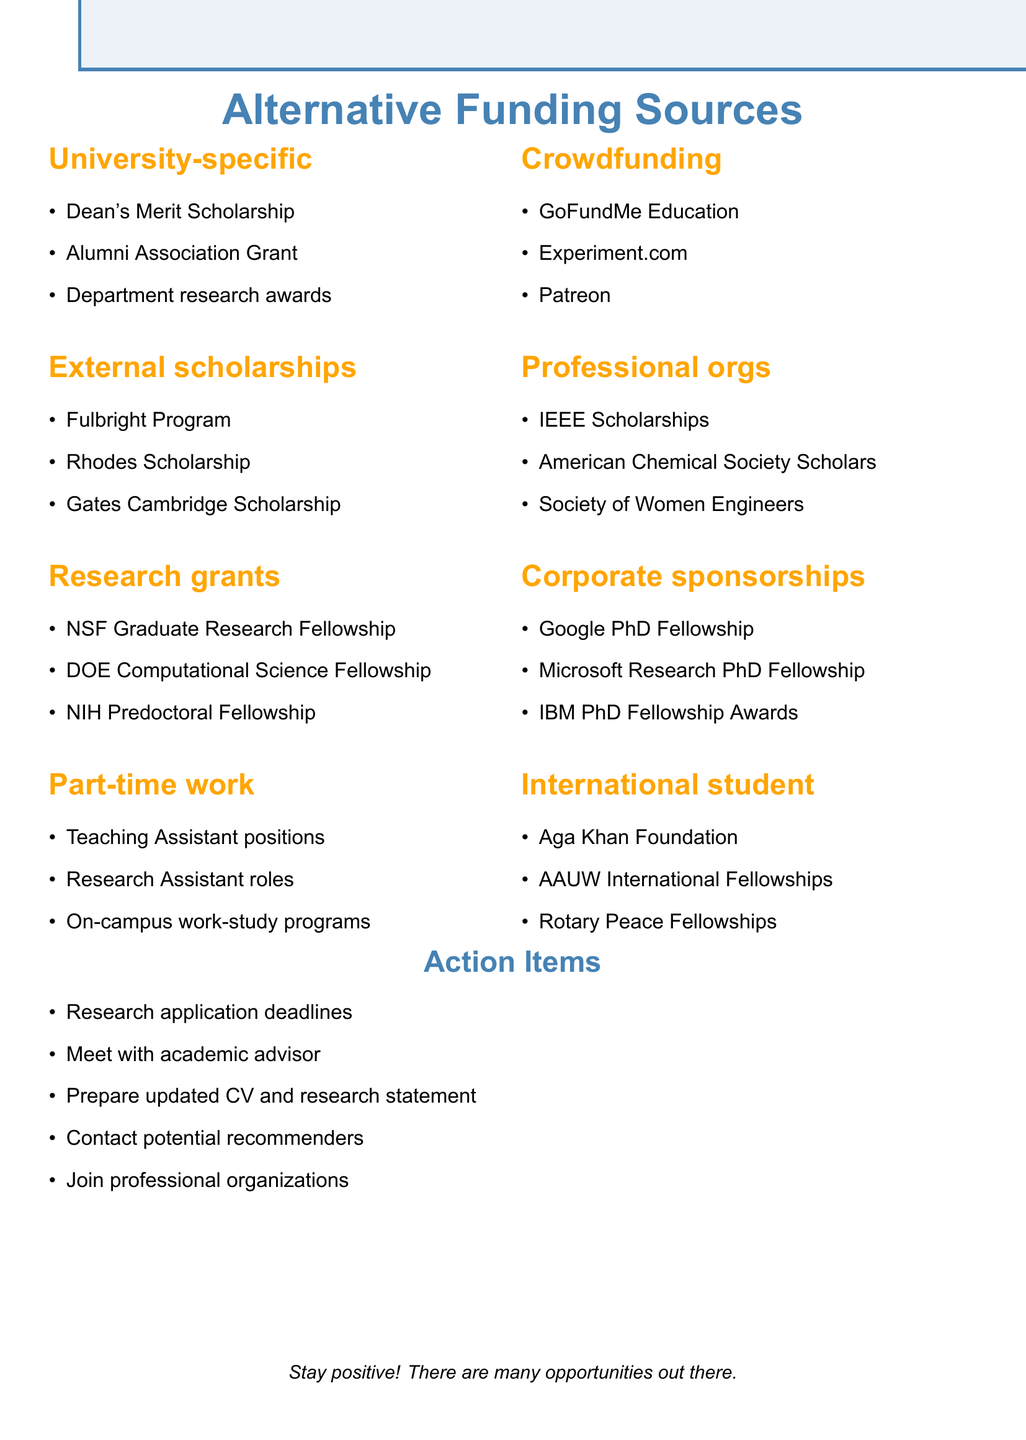What is one of the university-specific scholarships listed? The document lists various university-specific scholarships, including the Dean's Merit Scholarship as one of the options.
Answer: Dean's Merit Scholarship Name a professional organization that offers scholarships. The document mentions several professional organizations that provide scholarships, such as the IEEE Scholarships as an example.
Answer: IEEE Scholarships How many external scholarships are mentioned in the document? The document lists three external scholarships, including the Fulbright Program, Rhodes Scholarship, and Gates Cambridge Scholarship, indicating the count is three.
Answer: 3 What is one action item related to preparing for funding applications? The document outlines various action items, including preparing an updated CV and research statement as one key task.
Answer: Prepare updated CV and research statement Which category includes part-time work opportunities? The document specifically categorizes part-time work opportunities separately, indicating it is included under that category.
Answer: Part-time work opportunities 